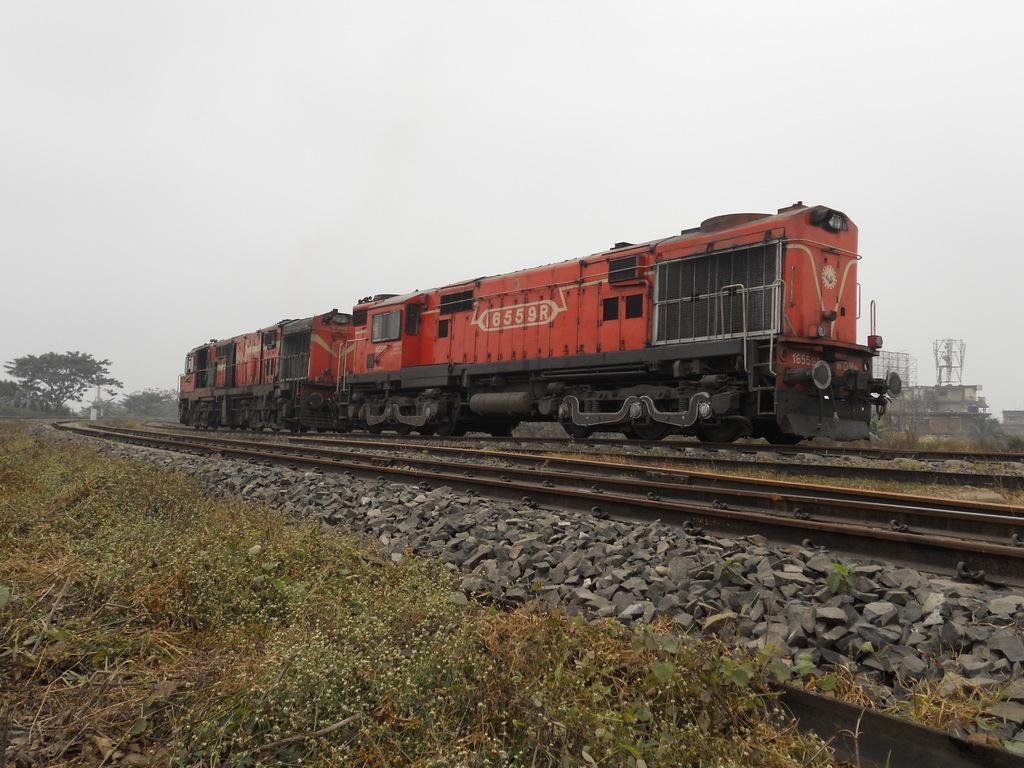Please provide a concise description of this image. This image is taken outdoors. At the top of the image there is the sky. At the bottom of the image there is a ground with grass on it and there are a few plants on the ground. In the background there are a few trees. There is a tower and there is a building. A train is moving on the track and there are two tracks and there are many pebbles. 